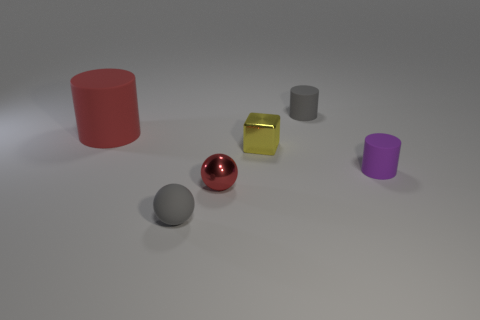There is a tiny yellow shiny object; are there any small yellow cubes left of it?
Offer a terse response. No. How many tiny gray things are the same shape as the purple thing?
Ensure brevity in your answer.  1. Are the tiny gray sphere and the cylinder to the left of the gray cylinder made of the same material?
Provide a succinct answer. Yes. How many big matte cylinders are there?
Keep it short and to the point. 1. What size is the shiny object that is in front of the small metallic cube?
Your answer should be compact. Small. How many blocks have the same size as the gray cylinder?
Keep it short and to the point. 1. There is a object that is both left of the tiny red ball and behind the small gray rubber ball; what material is it made of?
Provide a short and direct response. Rubber. There is another cylinder that is the same size as the gray cylinder; what is it made of?
Provide a succinct answer. Rubber. There is a sphere right of the tiny gray object that is to the left of the matte cylinder behind the big object; how big is it?
Your answer should be very brief. Small. There is a gray cylinder that is made of the same material as the tiny purple cylinder; what size is it?
Provide a succinct answer. Small. 